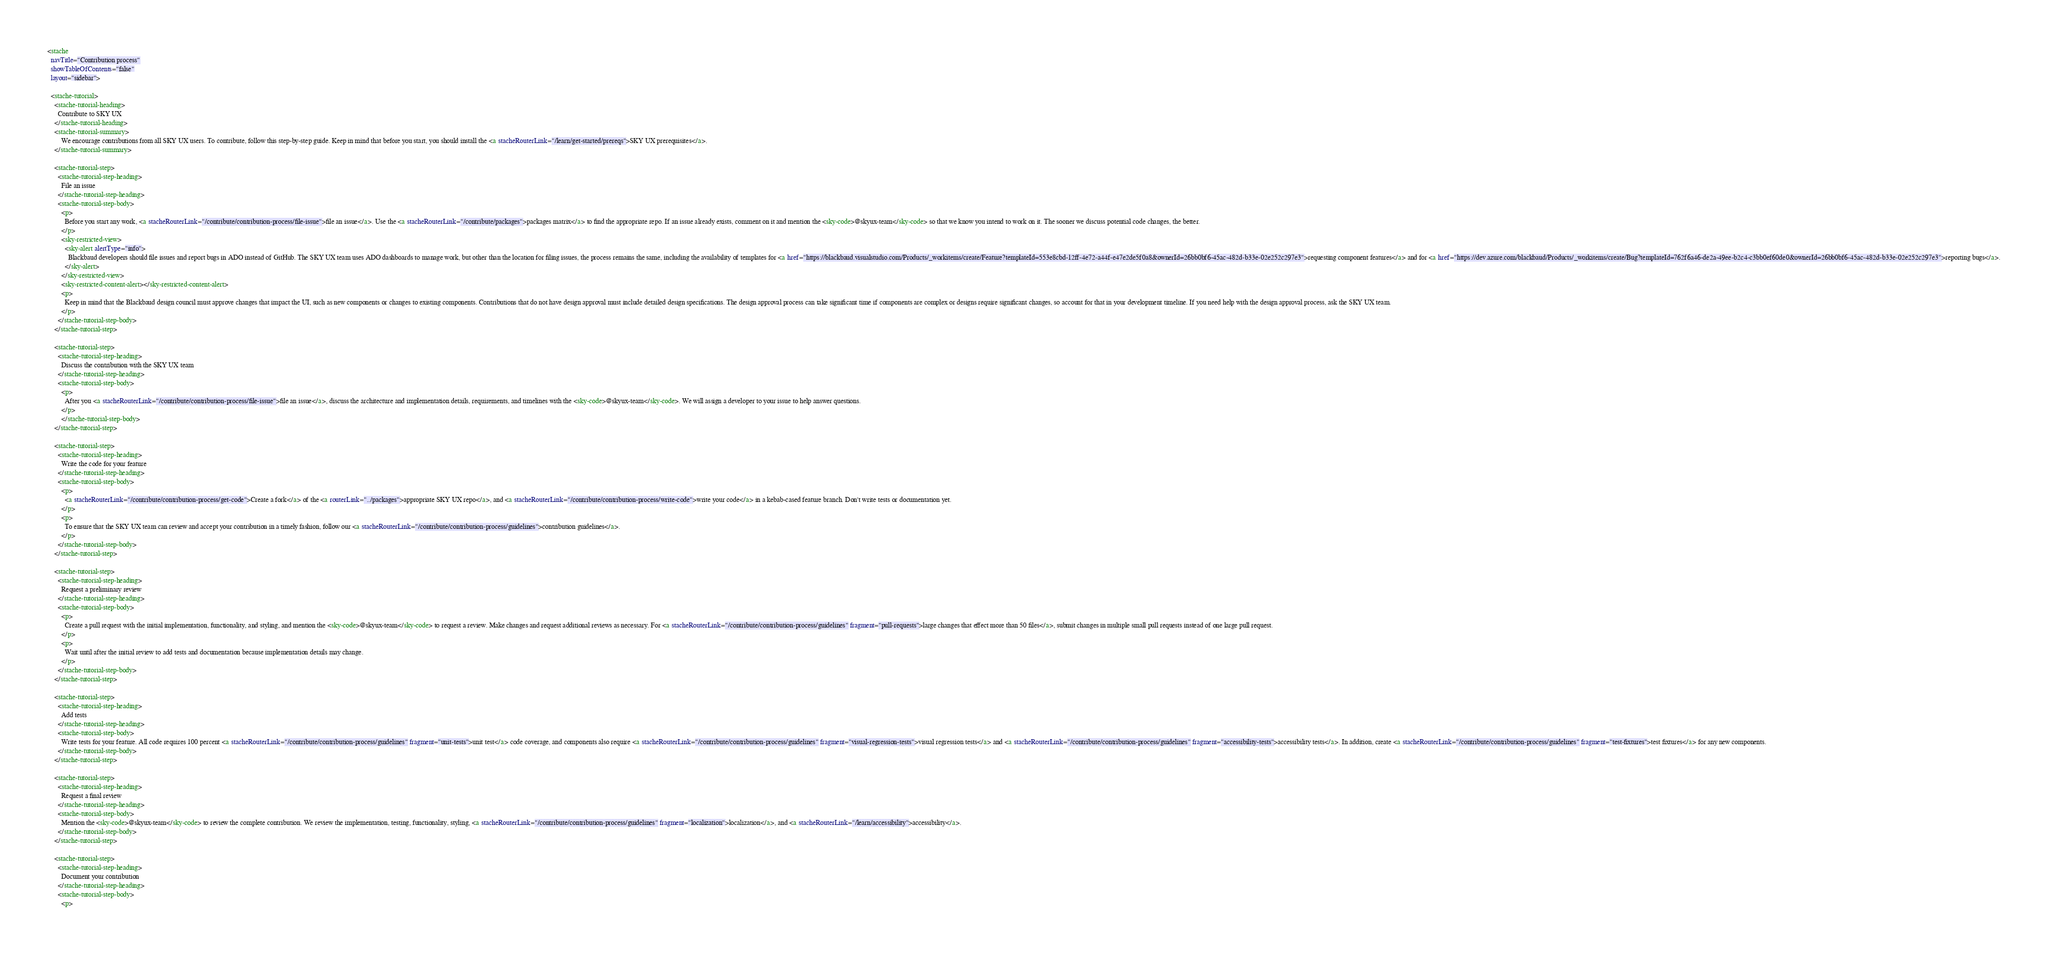Convert code to text. <code><loc_0><loc_0><loc_500><loc_500><_HTML_><stache
  navTitle="Contribution process"
  showTableOfContents="false"
  layout="sidebar">

  <stache-tutorial>
    <stache-tutorial-heading>
      Contribute to SKY UX
    </stache-tutorial-heading>
    <stache-tutorial-summary>
        We encourage contributions from all SKY UX users. To contribute, follow this step-by-step guide. Keep in mind that before you start, you should install the <a stacheRouterLink="/learn/get-started/prereqs">SKY UX prerequisites</a>.
    </stache-tutorial-summary>

    <stache-tutorial-step>
      <stache-tutorial-step-heading>
        File an issue
      </stache-tutorial-step-heading>
      <stache-tutorial-step-body>
        <p>
          Before you start any work, <a stacheRouterLink="/contribute/contribution-process/file-issue">file an issue</a>. Use the <a stacheRouterLink="/contribute/packages">packages matrix</a> to find the appropriate repo. If an issue already exists, comment on it and mention the <sky-code>@skyux-team</sky-code> so that we know you intend to work on it. The sooner we discuss potential code changes, the better.
        </p>
        <sky-restricted-view>
          <sky-alert alertType="info">
            Blackbaud developers should file issues and report bugs in ADO instead of GitHub. The SKY UX team uses ADO dashboards to manage work, but other than the location for filing issues, the process remains the same, including the availability of templates for <a href="https://blackbaud.visualstudio.com/Products/_workitems/create/Feature?templateId=553e8cbd-12ff-4e72-a44f-e47e2de5f0a8&ownerId=26bb0bf6-45ac-482d-b33e-02e252c297e3">requesting component features</a> and for <a href="https://dev.azure.com/blackbaud/Products/_workitems/create/Bug?templateId=762f6a46-de2a-49ee-b2c4-c3bb0ef60de0&ownerId=26bb0bf6-45ac-482d-b33e-02e252c297e3">reporting bugs</a>.
          </sky-alert>
        </sky-restricted-view>
        <sky-restricted-content-alert></sky-restricted-content-alert>
        <p>
          Keep in mind that the Blackbaud design council must approve changes that impact the UI, such as new components or changes to existing components. Contributions that do not have design approval must include detailed design specifications. The design approval process can take significant time if components are complex or designs require significant changes, so account for that in your development timeline. If you need help with the design approval process, ask the SKY UX team.
        </p>
      </stache-tutorial-step-body>
    </stache-tutorial-step>

    <stache-tutorial-step>
      <stache-tutorial-step-heading>
        Discuss the contribution with the SKY UX team
      </stache-tutorial-step-heading>
      <stache-tutorial-step-body>
        <p>
          After you <a stacheRouterLink="/contribute/contribution-process/file-issue">file an issue</a>, discuss the architecture and implementation details, requirements, and timelines with the <sky-code>@skyux-team</sky-code>. We will assign a developer to your issue to help answer questions.
        </p>
        </stache-tutorial-step-body>
    </stache-tutorial-step>

    <stache-tutorial-step>
      <stache-tutorial-step-heading>
        Write the code for your feature
      </stache-tutorial-step-heading>
      <stache-tutorial-step-body>
        <p>
          <a stacheRouterLink="/contribute/contribution-process/get-code">Create a fork</a> of the <a routerLink="../packages">appropriate SKY UX repo</a>, and <a stacheRouterLink="/contribute/contribution-process/write-code">write your code</a> in a kebab-cased feature branch. Don't write tests or documentation yet.
        </p>
        <p>
          To ensure that the SKY UX team can review and accept your contribution in a timely fashion, follow our <a stacheRouterLink="/contribute/contribution-process/guidelines">contribution guidelines</a>.
        </p>
      </stache-tutorial-step-body>
    </stache-tutorial-step>

    <stache-tutorial-step>
      <stache-tutorial-step-heading>
        Request a preliminary review
      </stache-tutorial-step-heading>
      <stache-tutorial-step-body>
        <p>
          Create a pull request with the initial implementation, functionality, and styling, and mention the <sky-code>@skyux-team</sky-code> to request a review. Make changes and request additional reviews as necessary. For <a stacheRouterLink="/contribute/contribution-process/guidelines" fragment="pull-requests">large changes that effect more than 50 files</a>, submit changes in multiple small pull requests instead of one large pull request.
        </p>
        <p>
          Wait until after the initial review to add tests and documentation because implementation details may change.
        </p>
      </stache-tutorial-step-body>
    </stache-tutorial-step>

    <stache-tutorial-step>
      <stache-tutorial-step-heading>
        Add tests
      </stache-tutorial-step-heading>
      <stache-tutorial-step-body>
        Write tests for your feature. All code requires 100 percent <a stacheRouterLink="/contribute/contribution-process/guidelines" fragment="unit-tests">unit test</a> code coverage, and components also require <a stacheRouterLink="/contribute/contribution-process/guidelines" fragment="visual-regression-tests">visual regression tests</a> and <a stacheRouterLink="/contribute/contribution-process/guidelines" fragment="accessibility-tests">accessibility tests</a>. In addition, create <a stacheRouterLink="/contribute/contribution-process/guidelines" fragment="test-fixtures">test fixtures</a> for any new components.
      </stache-tutorial-step-body>
    </stache-tutorial-step>

    <stache-tutorial-step>
      <stache-tutorial-step-heading>
        Request a final review
      </stache-tutorial-step-heading>
      <stache-tutorial-step-body>
        Mention the <sky-code>@skyux-team</sky-code> to review the complete contribution. We review the implementation, testing, functionality, styling, <a stacheRouterLink="/contribute/contribution-process/guidelines" fragment="localization">localization</a>, and <a stacheRouterLink="/learn/accessibility">accessibility</a>.
      </stache-tutorial-step-body>
    </stache-tutorial-step>

    <stache-tutorial-step>
      <stache-tutorial-step-heading>
        Document your contribution
      </stache-tutorial-step-heading>
      <stache-tutorial-step-body>
        <p></code> 